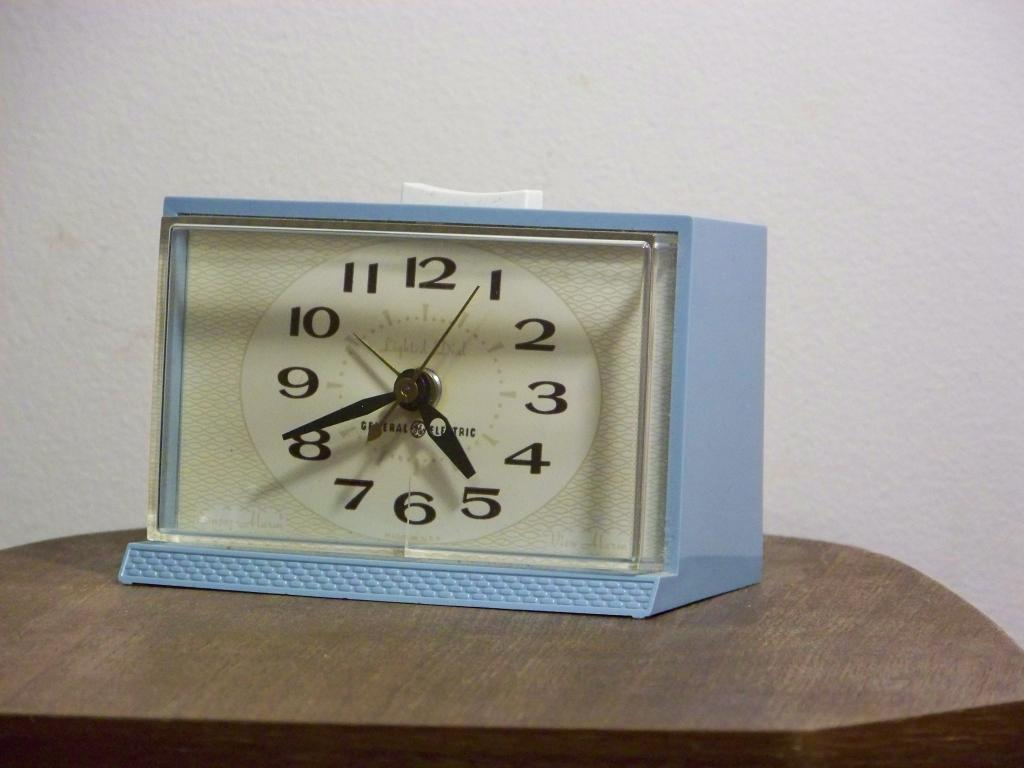<image>
Present a compact description of the photo's key features. A pale blue clock showing that the time is twenty minutes to five. 